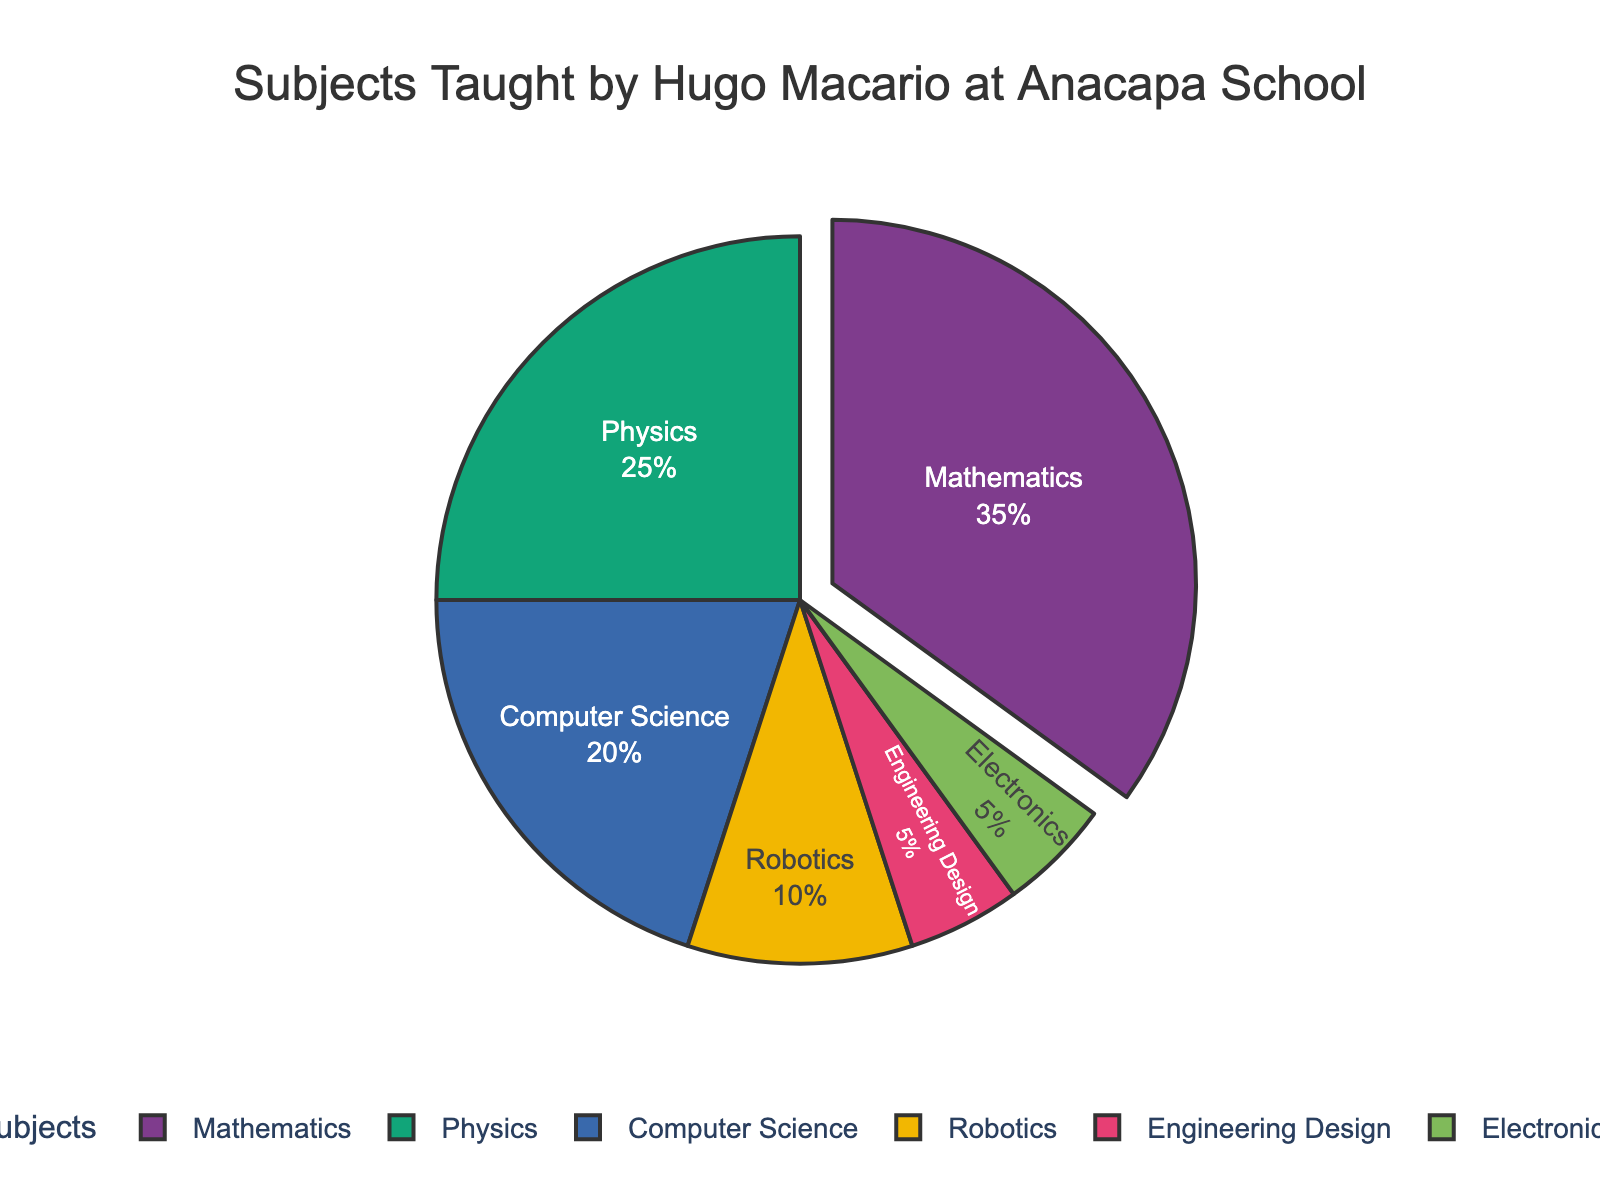What percentage of subjects taught by Hugo Macario at Anacapa School does Mathematics represent? The pie chart indicates the percentage of each subject taught by Hugo Macario. Mathematics is shown to represent 35%.
Answer: 35% How much more percentage does Mathematics represent compared to Physics? From the pie chart, we see Mathematics is 35% and Physics is 25%. The difference between them is 35% - 25% = 10%.
Answer: 10% Which subject has the smallest representation in the pie chart, and what is its percentage? The smallest slices in the pie chart correspond to the subjects with the least percentage. Both Engineering Design and Electronics are represented as the smallest slices, each having a percentage of 5%.
Answer: Engineering Design and Electronics, 5% What is the combined percentage of subjects related to technology (Computer Science and Robotics)? The percentages for Computer Science and Robotics are 20% and 10% respectively. Adding them together gives 20% + 10% = 30%.
Answer: 30% Between Computer Science and Engineering Design, which subject has a higher percentage, and by how much? The pie chart shows Computer Science at 20% and Engineering Design at 5%. The difference is 20% -5% = 15%.
Answer: Computer Science by 15% Are there any subjects that have the same percentage representation? If so, which? By observing the pie chart, we see that Electronics and Engineering Design both have a percentage representation of 5%, making them equal.
Answer: Electronics and Engineering Design If Math and Physics were combined into a single category labeled "STEM Core," what would be the new percentage representation for this category? Math is 35% and Physics is 25%. Combining these gives 35% + 25% = 60%.
Answer: 60% How much larger is the percentage for Mathematics than the percentage for all the Engineering subjects combined (Engineering Design and Electronics)? Mathematics has a percentage of 35%. The combined percentage of Engineering Design and Electronics is 5% + 5% = 10%. The difference is 35% - 10% = 25%.
Answer: 25% How does the percentage for Robotics compare visually to the percentage for Computer Science? From the pie chart, it is evident that the segment for Computer Science (20%) is larger than the segment for Robotics (10%).
Answer: Computer Science is larger than Robotics What percentage of subjects are not related to Mathematics or Physics? The percentages for Mathematics and Physics are 35% and 25%, respectively. The total percentage for these subjects is 35% + 25% = 60%. Subtracting this from 100% gives 100% - 60% = 40%.
Answer: 40% 